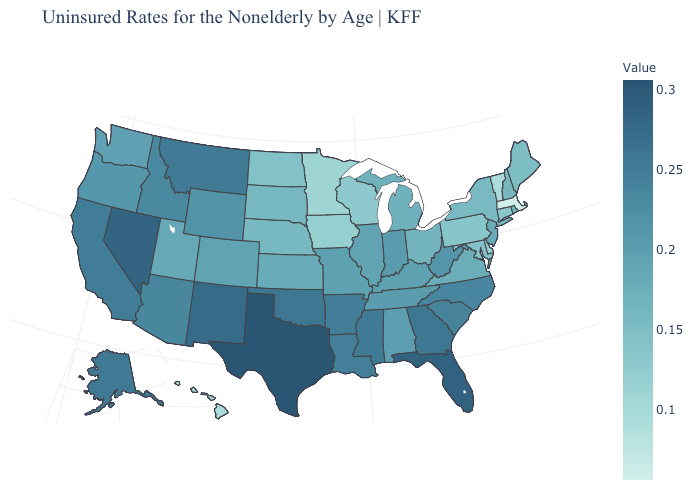Does New Hampshire have a lower value than South Carolina?
Keep it brief. Yes. Among the states that border Indiana , does Michigan have the highest value?
Quick response, please. No. Does Alaska have the lowest value in the West?
Short answer required. No. Which states have the highest value in the USA?
Be succinct. Texas. Which states hav the highest value in the MidWest?
Write a very short answer. Indiana. Which states have the lowest value in the USA?
Short answer required. Massachusetts. 